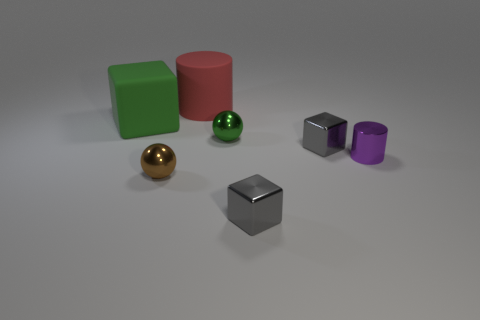Add 1 big green balls. How many objects exist? 8 Subtract all balls. How many objects are left? 5 Add 7 purple cylinders. How many purple cylinders exist? 8 Subtract 0 red balls. How many objects are left? 7 Subtract all gray blocks. Subtract all purple objects. How many objects are left? 4 Add 7 brown objects. How many brown objects are left? 8 